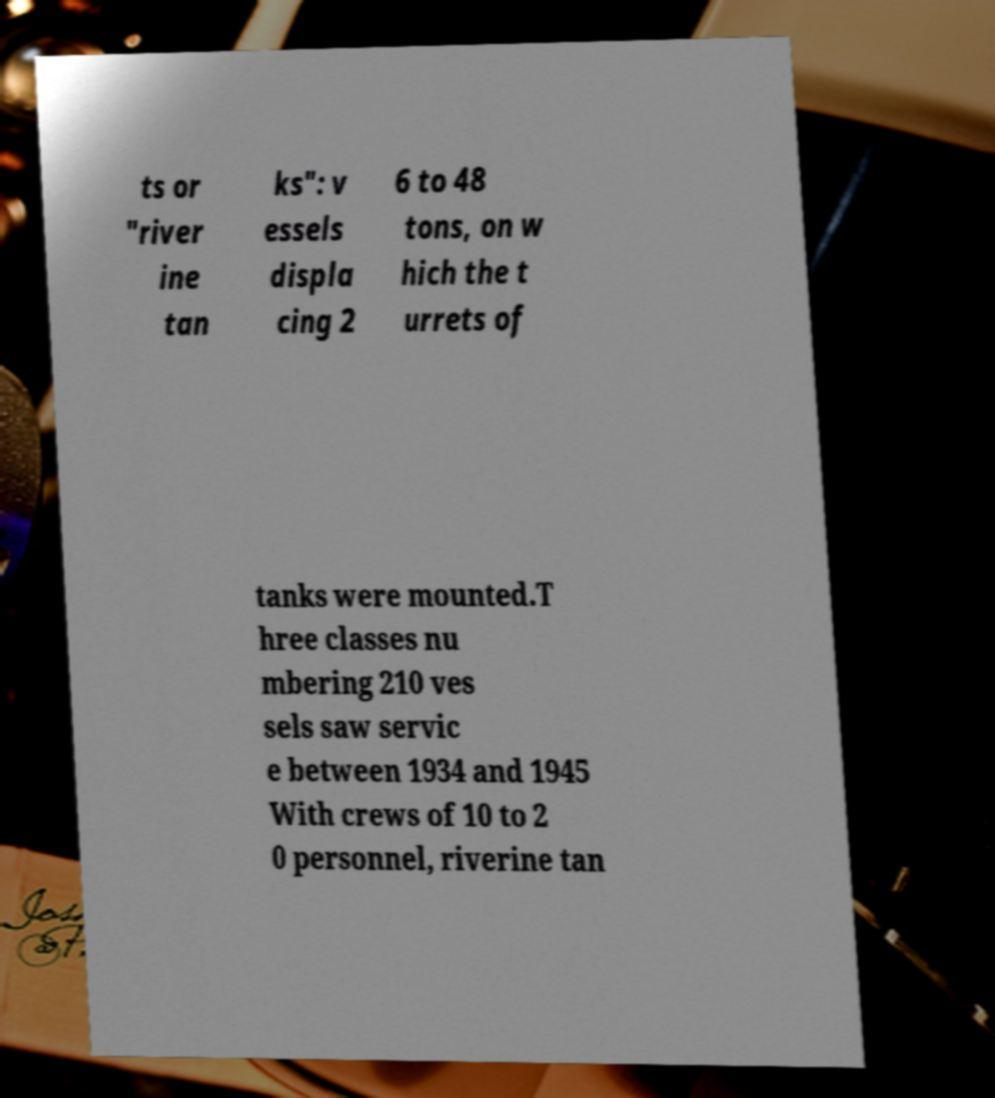I need the written content from this picture converted into text. Can you do that? ts or "river ine tan ks": v essels displa cing 2 6 to 48 tons, on w hich the t urrets of tanks were mounted.T hree classes nu mbering 210 ves sels saw servic e between 1934 and 1945 With crews of 10 to 2 0 personnel, riverine tan 